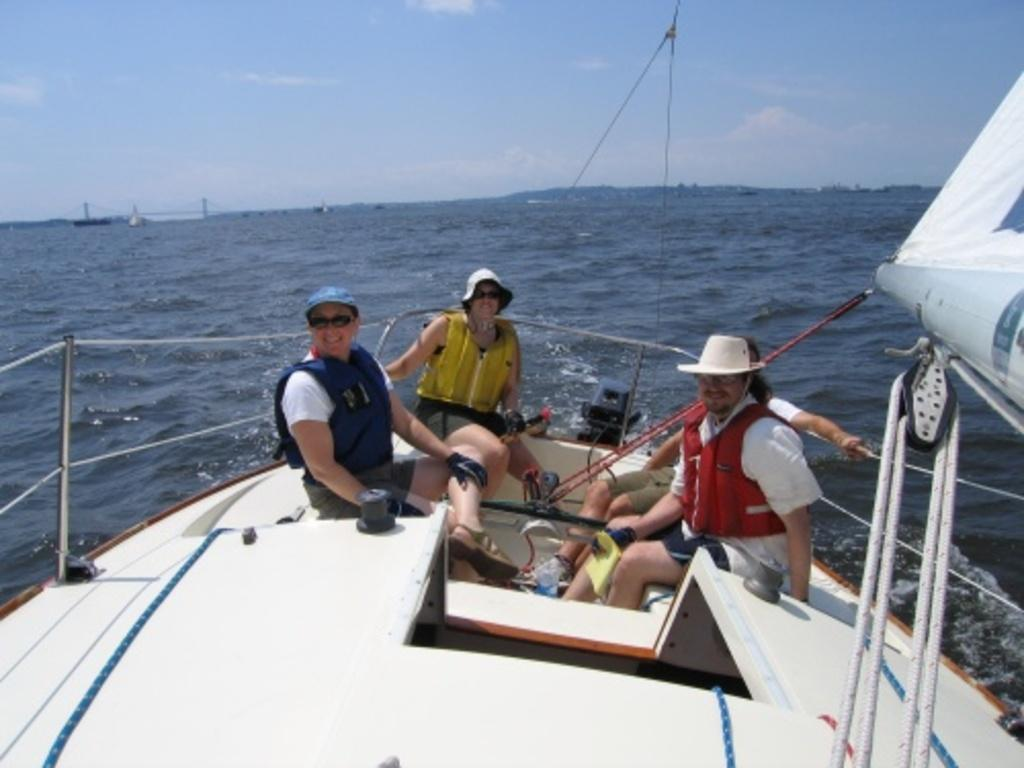What is the main subject in the center of the image? There is a ship in the center of the image. Where is the ship located? The ship is on the water. Are there any people on the ship? Yes, there are people in the ship. What else can be seen in the image besides the ship and people? There is water visible in the image. What type of map is being used by the governor in the image? There is no governor or map present in the image; it features a ship on the water with people on board. 